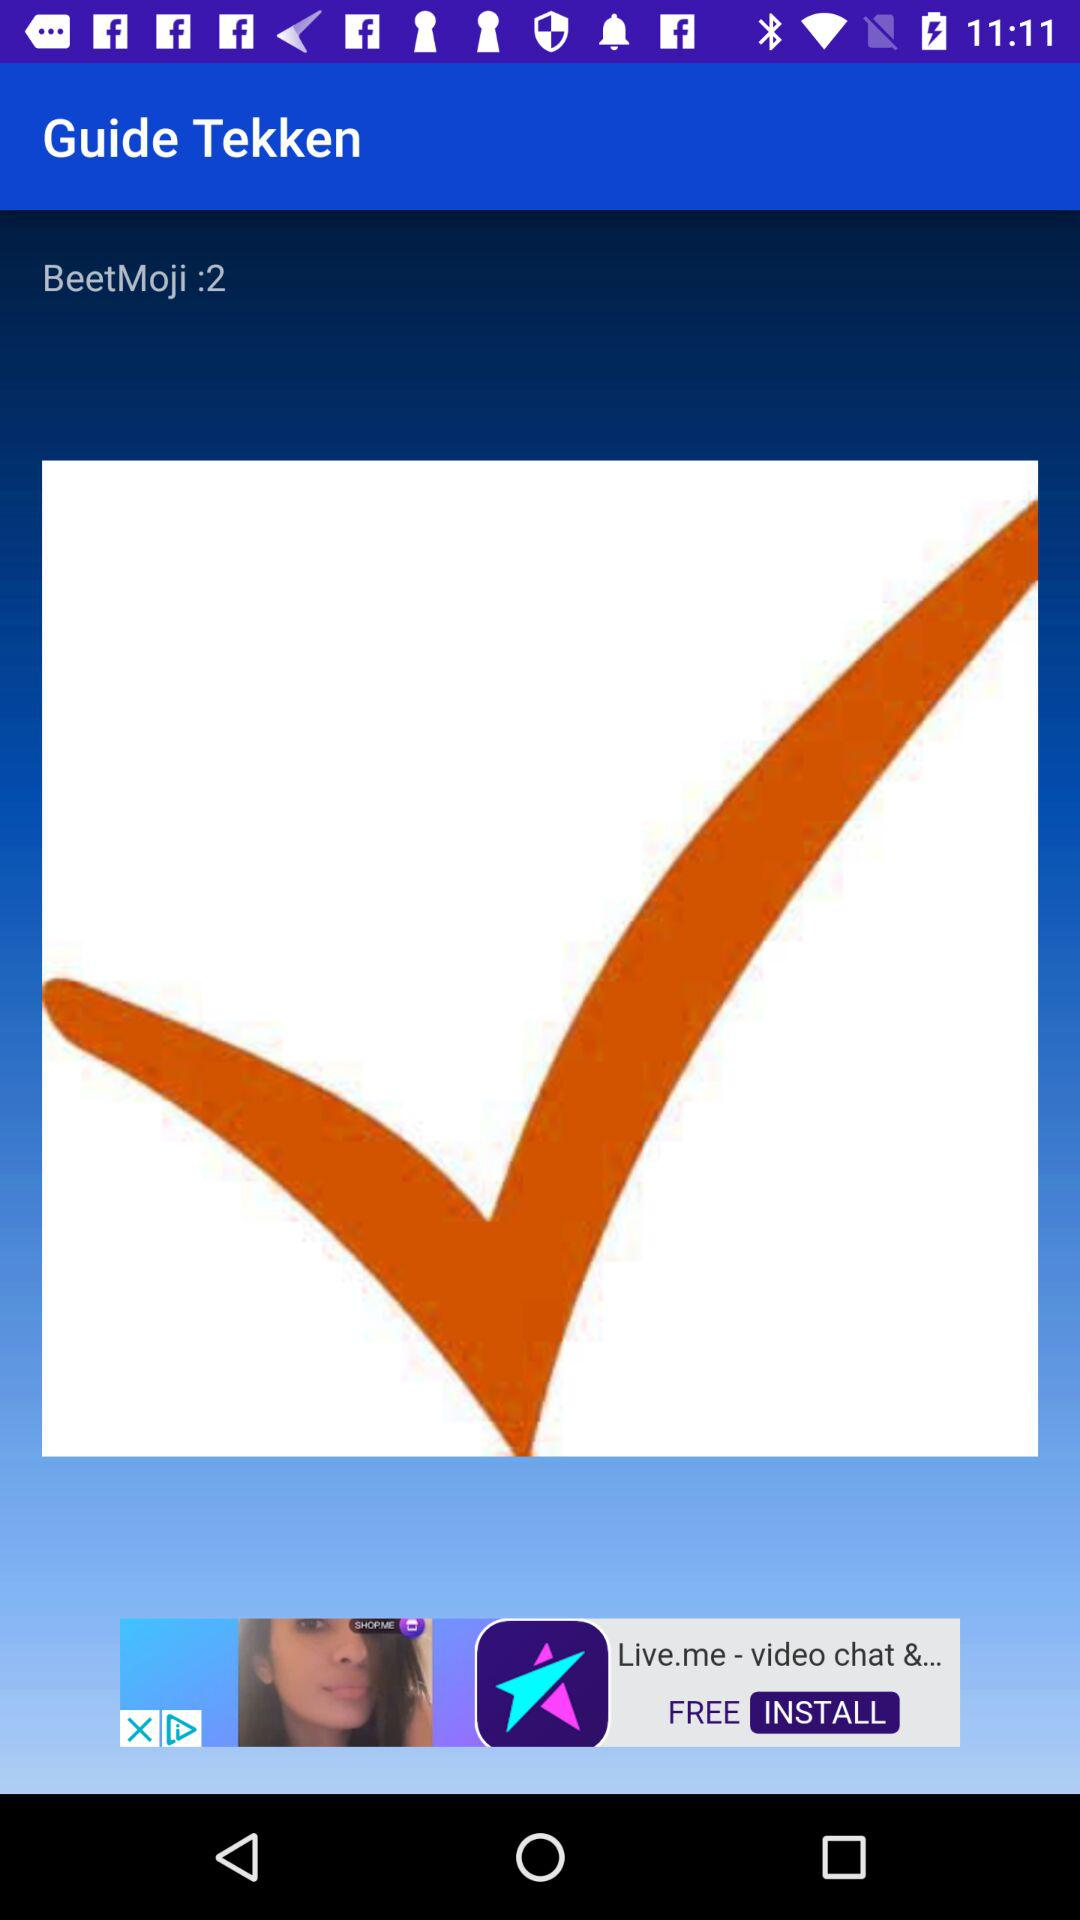What is the number for "BeetMoji"? The number for "BeetMoji" is 2. 